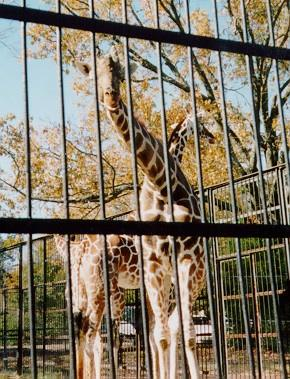What is between the is the fence made of?

Choices:
A) steel
B) wood
C) glass
D) plastic steel 